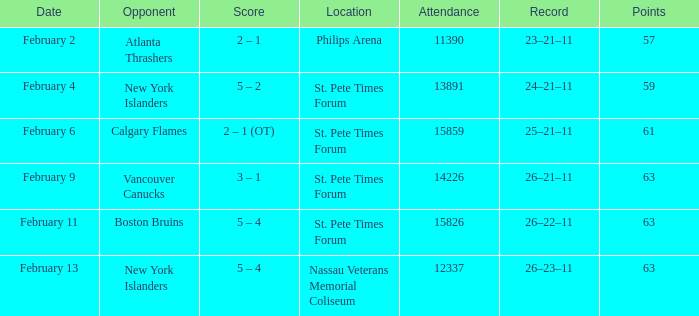What were the scores on february 9? 3 – 1. 